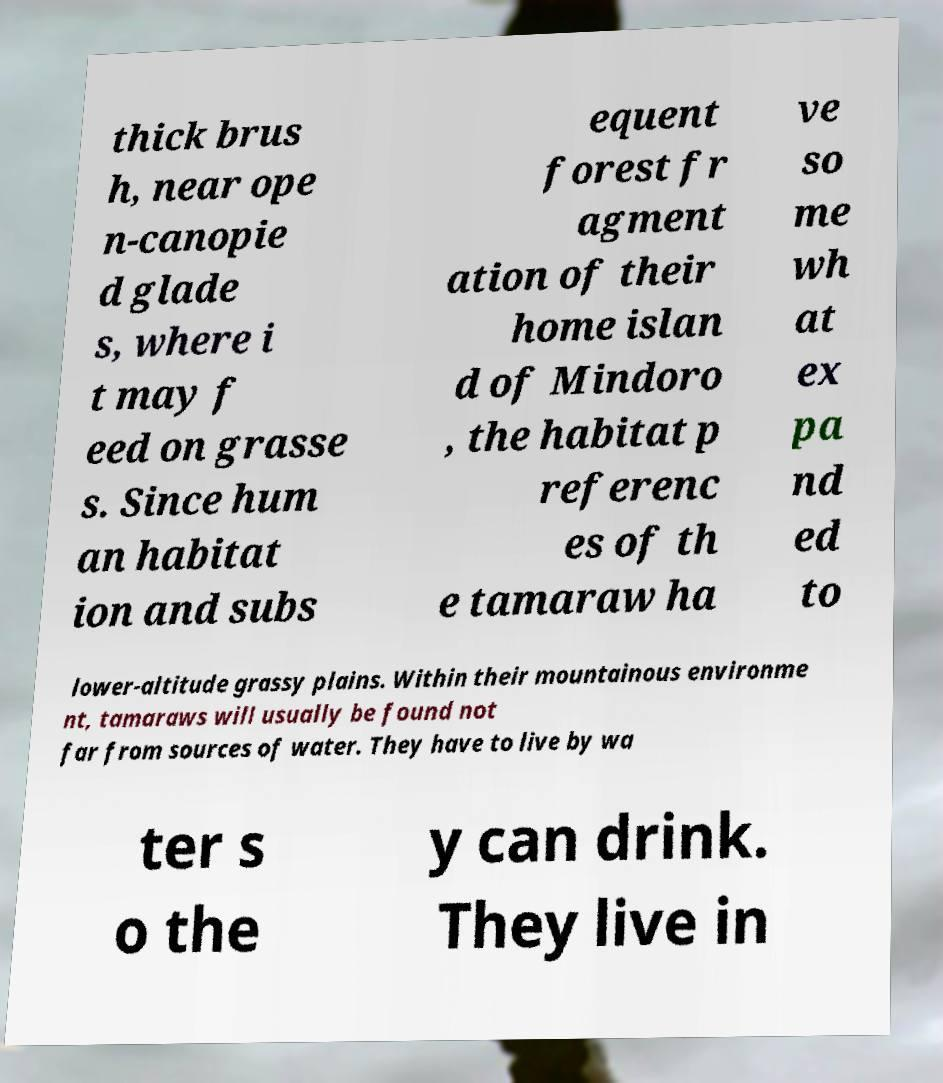There's text embedded in this image that I need extracted. Can you transcribe it verbatim? thick brus h, near ope n-canopie d glade s, where i t may f eed on grasse s. Since hum an habitat ion and subs equent forest fr agment ation of their home islan d of Mindoro , the habitat p referenc es of th e tamaraw ha ve so me wh at ex pa nd ed to lower-altitude grassy plains. Within their mountainous environme nt, tamaraws will usually be found not far from sources of water. They have to live by wa ter s o the y can drink. They live in 